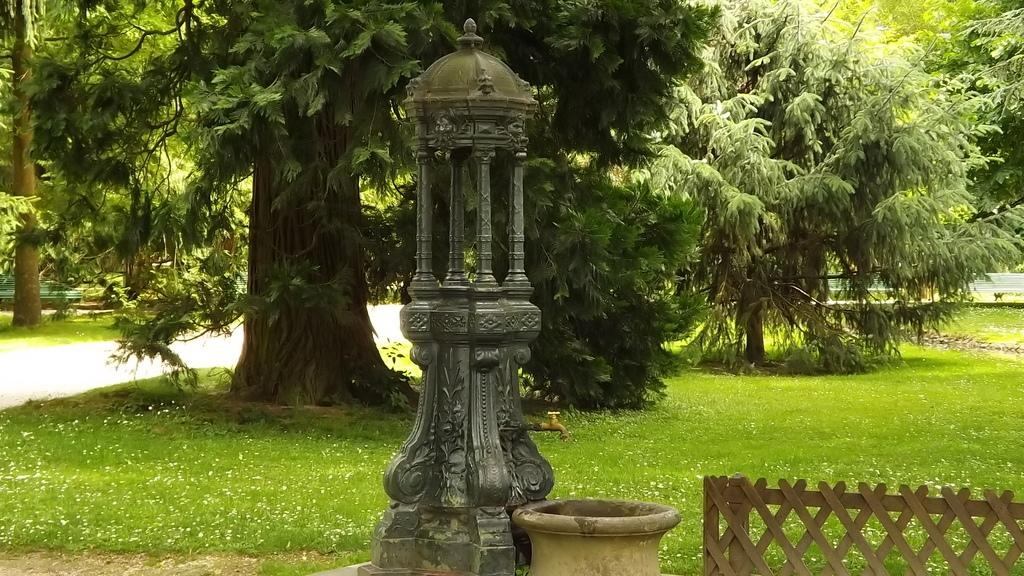What type of structure can be seen in the image? There is a fence in the image. Where is the tap located in the image? The tap is on the right side of the image. What is located at the bottom of the image? There is a pot. What type of vegetation is present in the image? There are trees in the image. What is covering the ground in the image? There is grass on the ground in the image. How many crows are perched on the fence in the image? There are no crows present in the image; it only features a fence, a tap, a pot, trees, and grass. What type of writing instrument is being used in the image? There is no writing instrument present in the image. 